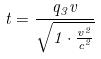<formula> <loc_0><loc_0><loc_500><loc_500>t = \frac { q _ { 3 } v } { \sqrt { 1 \cdot \frac { v ^ { 2 } } { c ^ { 2 } } } }</formula> 